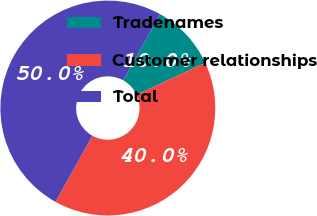Convert chart. <chart><loc_0><loc_0><loc_500><loc_500><pie_chart><fcel>Tradenames<fcel>Customer relationships<fcel>Total<nl><fcel>10.0%<fcel>40.0%<fcel>50.0%<nl></chart> 